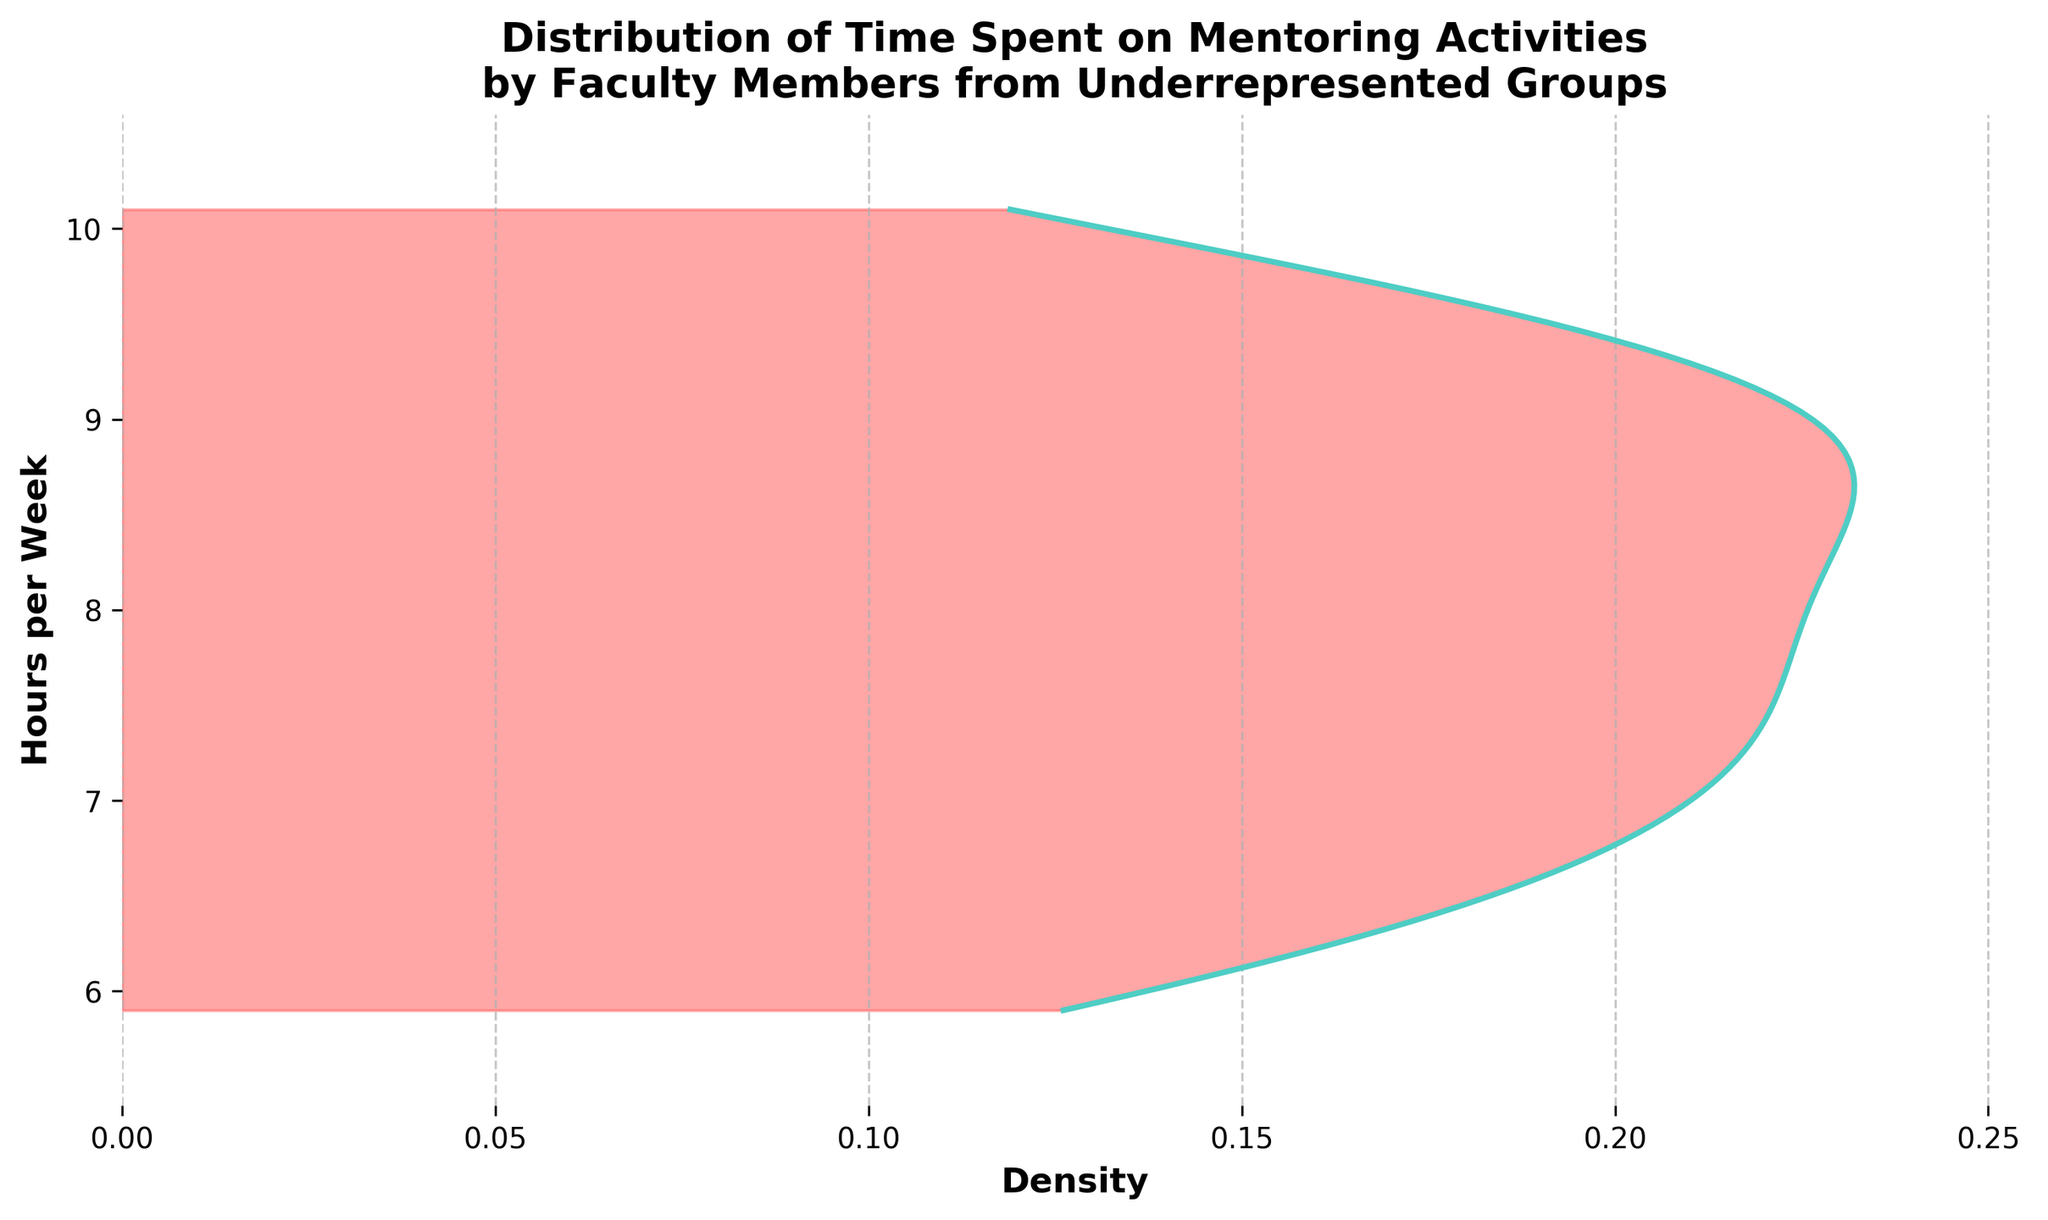what does the title of the figure indicate? The title of the figure indicates the distribution of time spent on mentoring activities by faculty members from underrepresented groups.
Answer: Distribution of Time Spent on Mentoring Activities by Faculty Members from Underrepresented Groups what does the y-axis represent in the figure? The y-axis represents the number of hours per week spent on mentoring activities by faculty members.
Answer: Hours per Week what color represents the density area in the plot? The density area in the plot is represented by a light red color.
Answer: light red what are the minimum and maximum values on the y-axis? The minimum value on the y-axis is 5.4 hours and the maximum value is 10.6 hours after calculating the range of the data plus a small margin.
Answer: 5.4, 10.6 which part of the plot has the highest density? The highest density can be identified from the region where the curve peaks most prominently which is around 8 hours per week.
Answer: around 8 hours per week compare the densities at 6 hours per week and 9 hours per week. Which one is higher? By observing the density plot curve, the density at 6 hours per week is lower than the density at 9 hours per week.
Answer: 9 hours per week what is the general trend of the density distribution in this plot? The general trend is that there is a peak around 8 hours per week and then it decreases towards both extremes (lower and higher hours per week).
Answer: peak around 8 hours and decreases towards lower and higher values how would you describe the variability of hours spent on mentoring based on the plot? The variability is moderate; there's a peak at around 8 hours, but the density covers a range of values indicating diversity in time commitment.
Answer: moderate what visual elements help indicate where the density plot peaks? The peak is indicated by the filled color area reaching its maximum width and the line plot reaching its highest point.
Answer: filled color area and line plot peak 